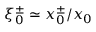<formula> <loc_0><loc_0><loc_500><loc_500>\xi _ { 0 } ^ { \pm } \simeq x _ { 0 } ^ { \pm } / x _ { 0 }</formula> 